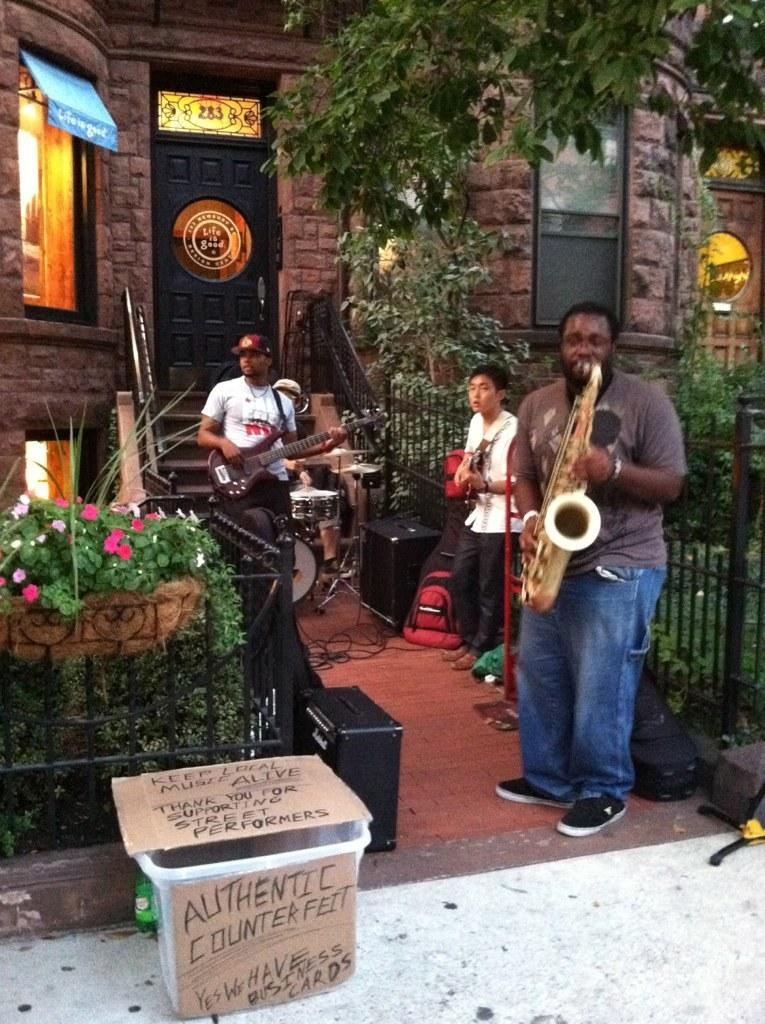What is happening in the image involving the group of people? The people are performing with musical instruments. Can you describe the setting in which the performance is taking place? There is a house in the background of the image, with a door and a window visible. What type of vegetation can be seen in the image? Plants and trees are present in the image. How many centimeters long is the feast depicted in the image? There is no feast present in the image; it features a group of people performing with musical instruments. 